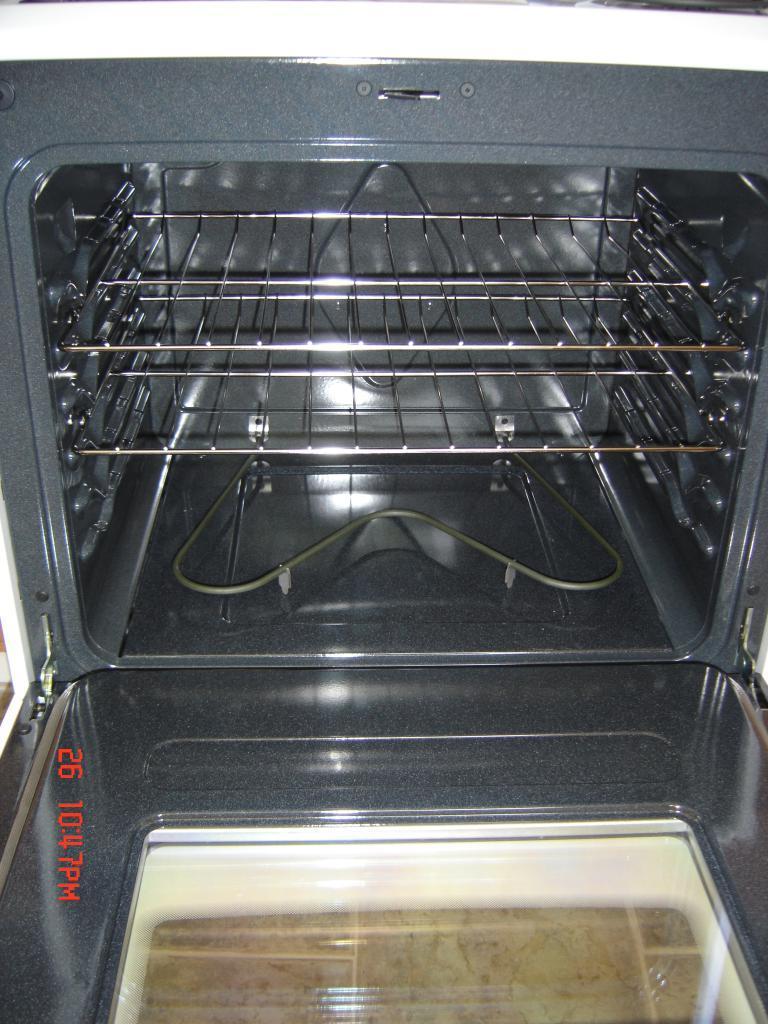Can you describe this image briefly? In this image there is an oven. There is a date and time on the left side of the image. 